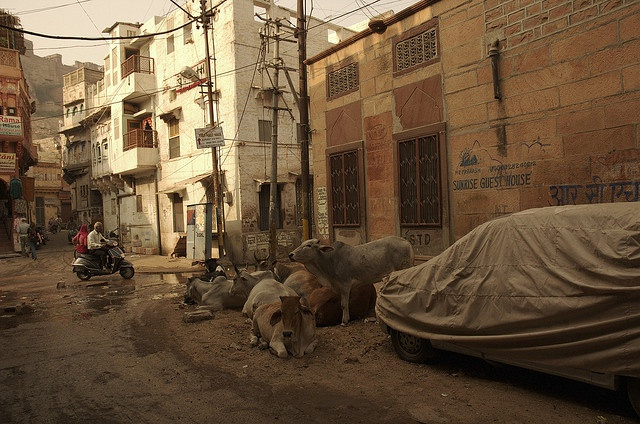Describe the objects in this image and their specific colors. I can see car in beige, black, maroon, and gray tones, cow in beige, black, and gray tones, cow in beige, black, maroon, and gray tones, cow in beige, gray, and black tones, and cow in black, maroon, and beige tones in this image. 